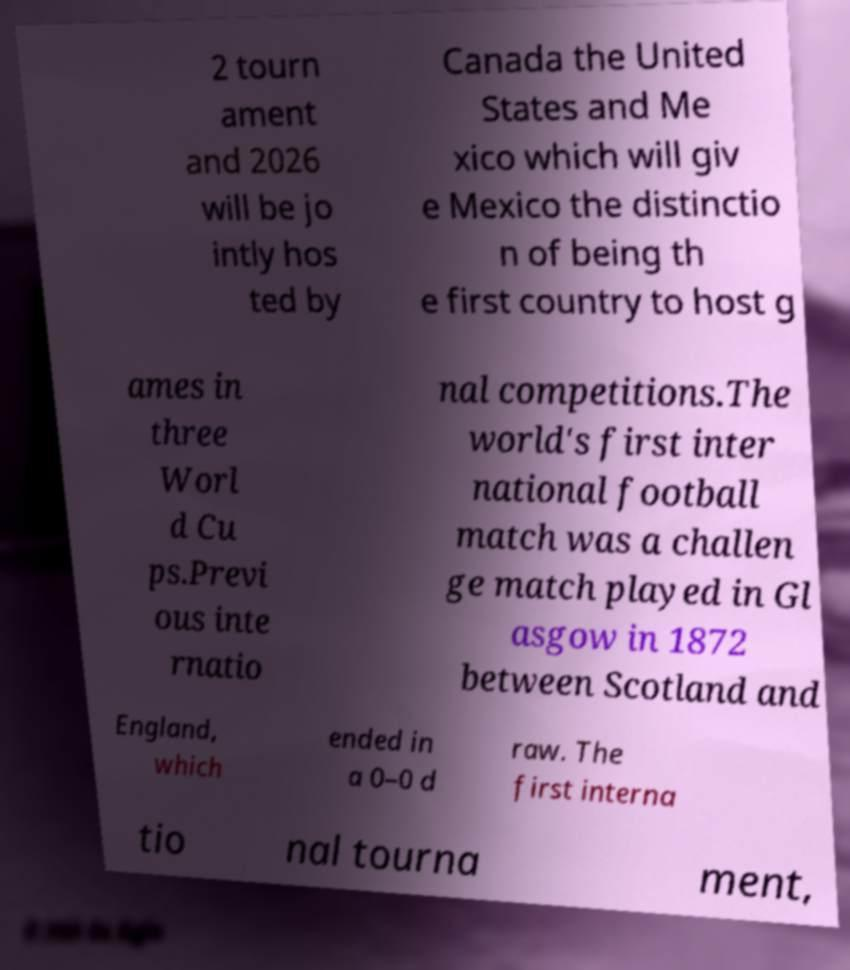There's text embedded in this image that I need extracted. Can you transcribe it verbatim? 2 tourn ament and 2026 will be jo intly hos ted by Canada the United States and Me xico which will giv e Mexico the distinctio n of being th e first country to host g ames in three Worl d Cu ps.Previ ous inte rnatio nal competitions.The world's first inter national football match was a challen ge match played in Gl asgow in 1872 between Scotland and England, which ended in a 0–0 d raw. The first interna tio nal tourna ment, 